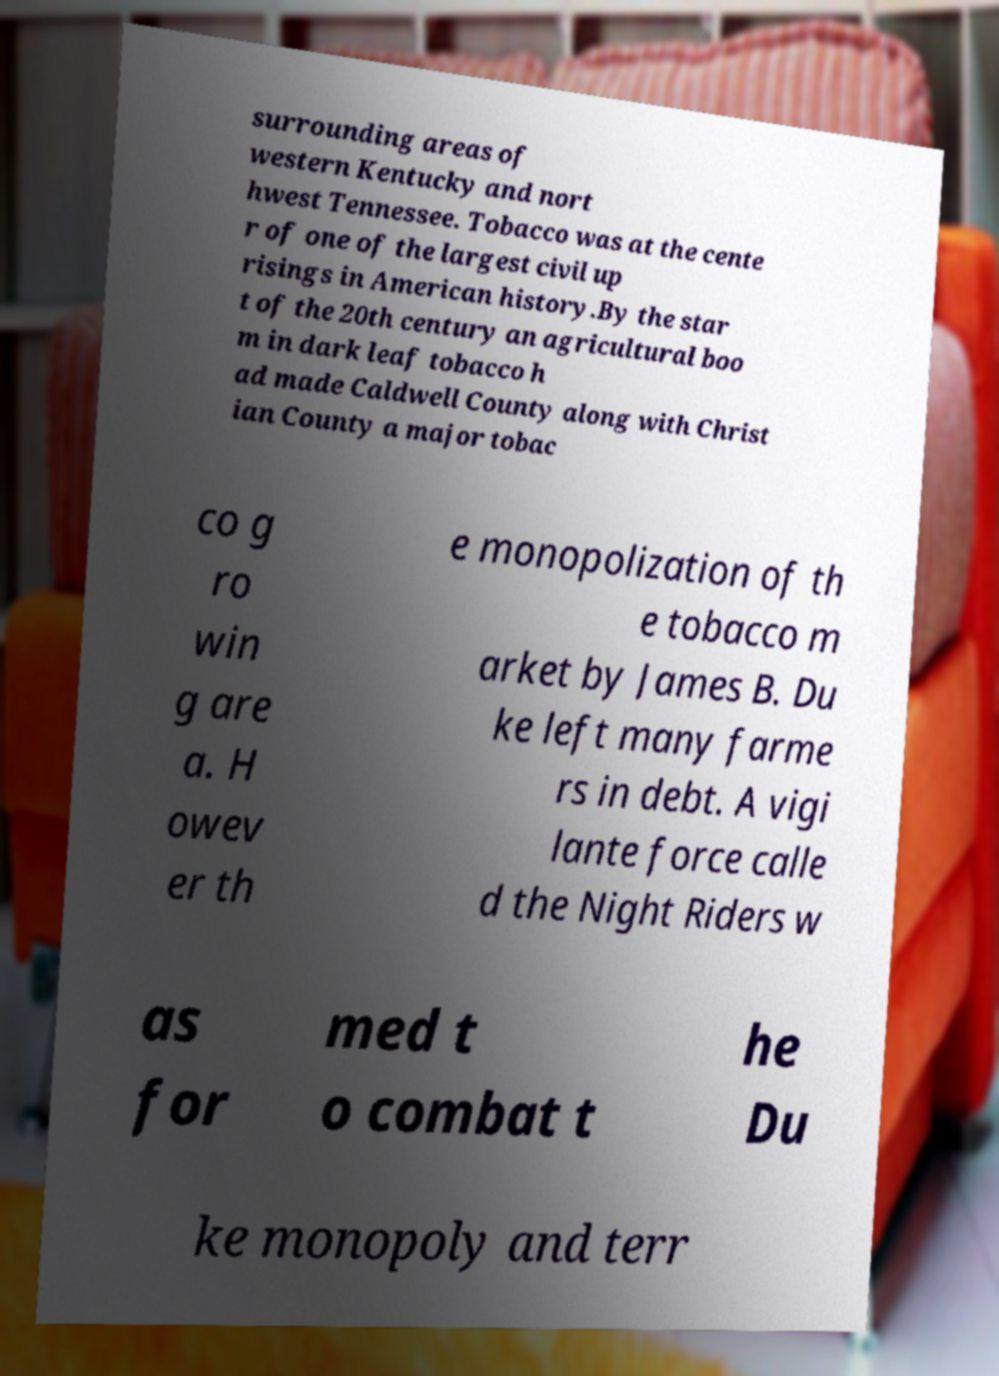There's text embedded in this image that I need extracted. Can you transcribe it verbatim? surrounding areas of western Kentucky and nort hwest Tennessee. Tobacco was at the cente r of one of the largest civil up risings in American history.By the star t of the 20th century an agricultural boo m in dark leaf tobacco h ad made Caldwell County along with Christ ian County a major tobac co g ro win g are a. H owev er th e monopolization of th e tobacco m arket by James B. Du ke left many farme rs in debt. A vigi lante force calle d the Night Riders w as for med t o combat t he Du ke monopoly and terr 